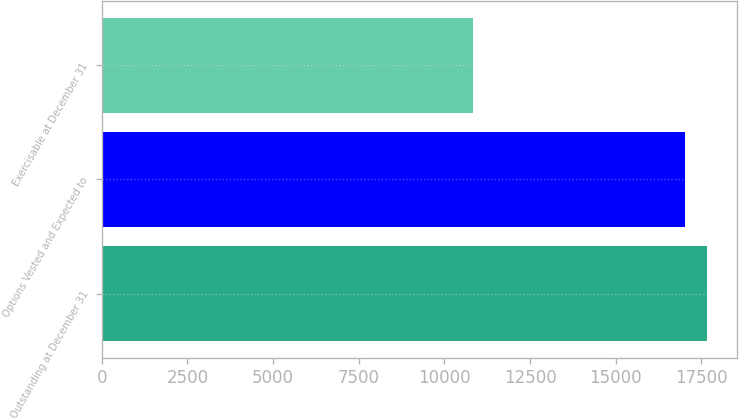<chart> <loc_0><loc_0><loc_500><loc_500><bar_chart><fcel>Outstanding at December 31<fcel>Options Vested and Expected to<fcel>Exercisable at December 31<nl><fcel>17654.9<fcel>17018<fcel>10829<nl></chart> 